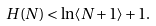<formula> <loc_0><loc_0><loc_500><loc_500>H ( N ) < \ln \langle N + 1 \rangle + 1 .</formula> 